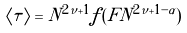Convert formula to latex. <formula><loc_0><loc_0><loc_500><loc_500>\langle \tau \rangle = N ^ { 2 \nu + 1 } f ( F N ^ { 2 \nu + 1 - \alpha } )</formula> 